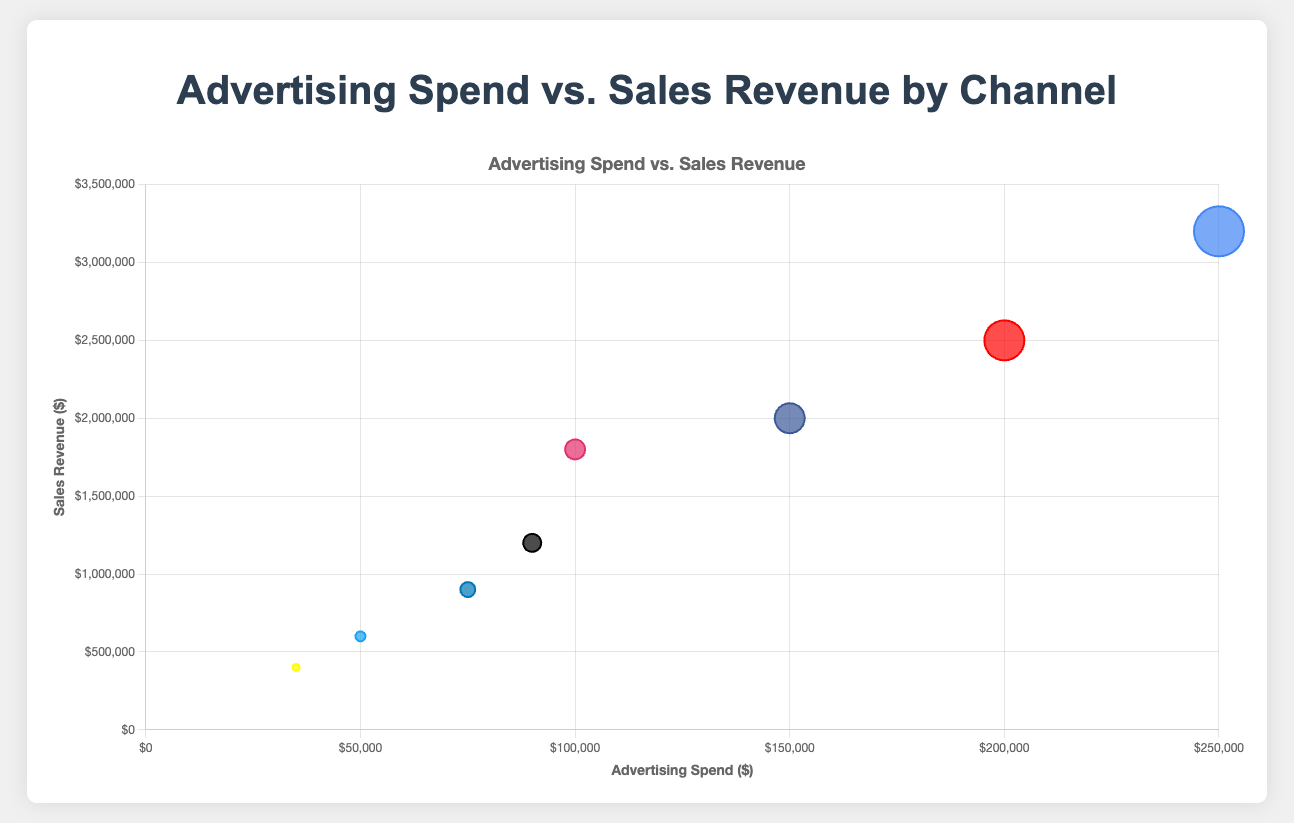What is the title of the chart? The title of the chart is usually found at the top and in this case, it states the main idea being visualized.
Answer: Advertising Spend vs. Sales Revenue by Channel How many channels are represented in the chart? By counting the number of bubbles in the chart, each representing a different channel, you can determine the number of channels.
Answer: 8 Which channel spent the most on advertising? The bubble farthest to the right on the x-axis represents the highest advertising spend.
Answer: Google Which channel has the largest bubble size? The largest bubble in terms of size indicates the highest "bubble_size" value.
Answer: Google What is the sales revenue of the channel with the smallest bubble size? Finding the smallest bubble and checking the corresponding sales revenue.
Answer: $400,000 (Snapchat) What is the difference in advertising spend between Facebook and Google? Subtract the advertising spend of Facebook from that of Google: $250,000 - $150,000.
Answer: $100,000 What is the combined sales revenue of all channels? Add up the sales revenue for all channels: $2,000,000 + $3,200,000 + $1,800,000 + $900,000 + $600,000 + $2,500,000 + $400,000 + $1,200,000.
Answer: $12,600,000 Which channel generates more sales revenue: Instagram or LinkedIn? Compare the y-values (sales revenue) of Instagram and LinkedIn bubbles.
Answer: Instagram Is there any channel with a higher sales revenue than its advertising spend but smaller than YouTube’s revenue? Compare each channel’s sales revenue to its advertising spend and check if it is smaller than YouTube’s $2,500,000.
Answer: TikTok with $1,200,000 Rank the channels by bubble size from largest to smallest. First, identify the bubble sizes and then rank them in descending order.
Answer: Google, YouTube, Facebook, Instagram, TikTok, LinkedIn, Twitter, Snapchat 